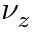Convert formula to latex. <formula><loc_0><loc_0><loc_500><loc_500>\nu _ { z }</formula> 